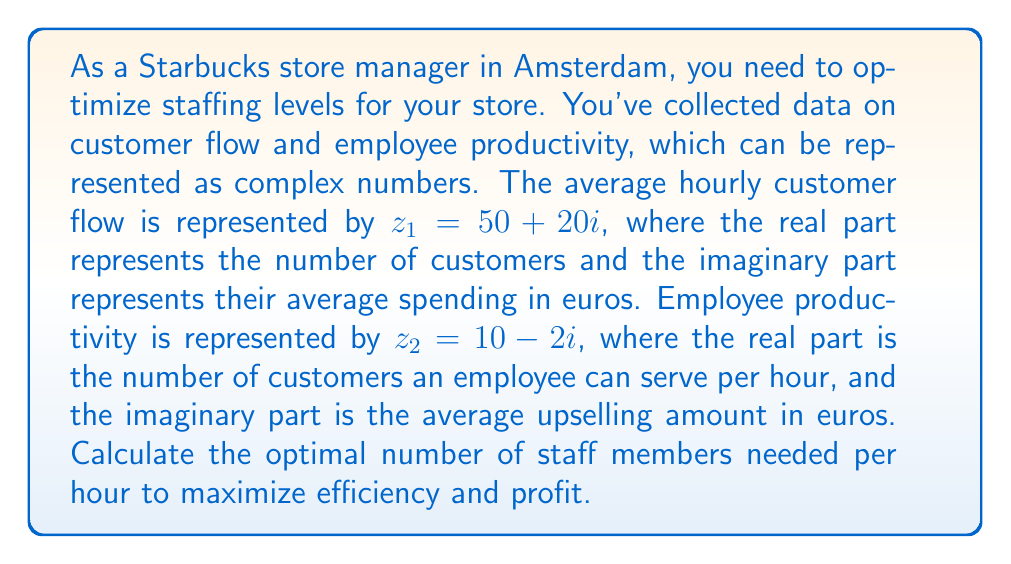Solve this math problem. To solve this problem, we'll use complex number operations:

1) First, we need to find the ratio of customer flow to employee productivity. This can be done by dividing $z_1$ by $z_2$:

   $$\frac{z_1}{z_2} = \frac{50 + 20i}{10 - 2i}$$

2) To divide complex numbers, we multiply both numerator and denominator by the complex conjugate of the denominator:

   $$\frac{z_1}{z_2} = \frac{(50 + 20i)(10 + 2i)}{(10 - 2i)(10 + 2i)}$$

3) Expand the numerator:
   $$(500 + 100i + 200i + 40i^2) = (500 + 300i - 40)$$
   $$(460 + 300i)$$

4) The denominator becomes:
   $$(10^2 + 2^2) = 104$$

5) Therefore, the division results in:

   $$\frac{460 + 300i}{104} = \frac{460}{104} + \frac{300}{104}i$$

6) Simplify:
   $$4.42 + 2.88i$$

7) The real part of this result (4.42) represents the optimal number of staff members needed per hour.

8) Since we can't have a fractional number of staff members, we round up to the nearest whole number.
Answer: The optimal number of staff members needed per hour is 5. 